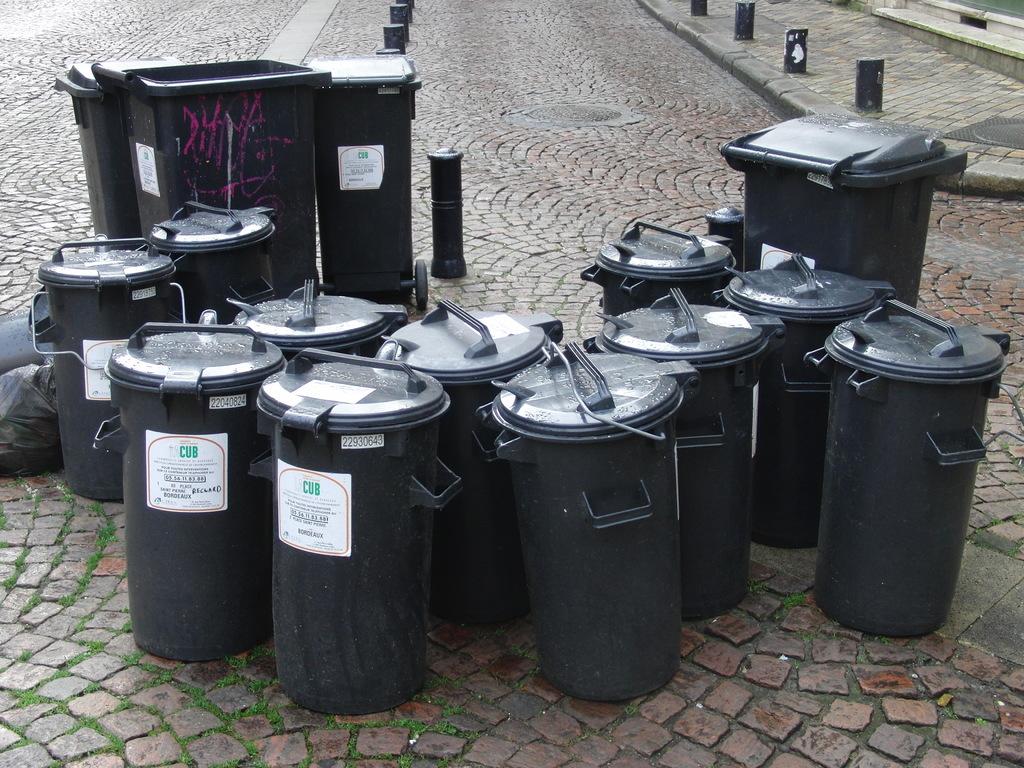What is written on the white labels on these containers?
Your answer should be very brief. Cub. Its dustibin box?
Offer a very short reply. Yes. 